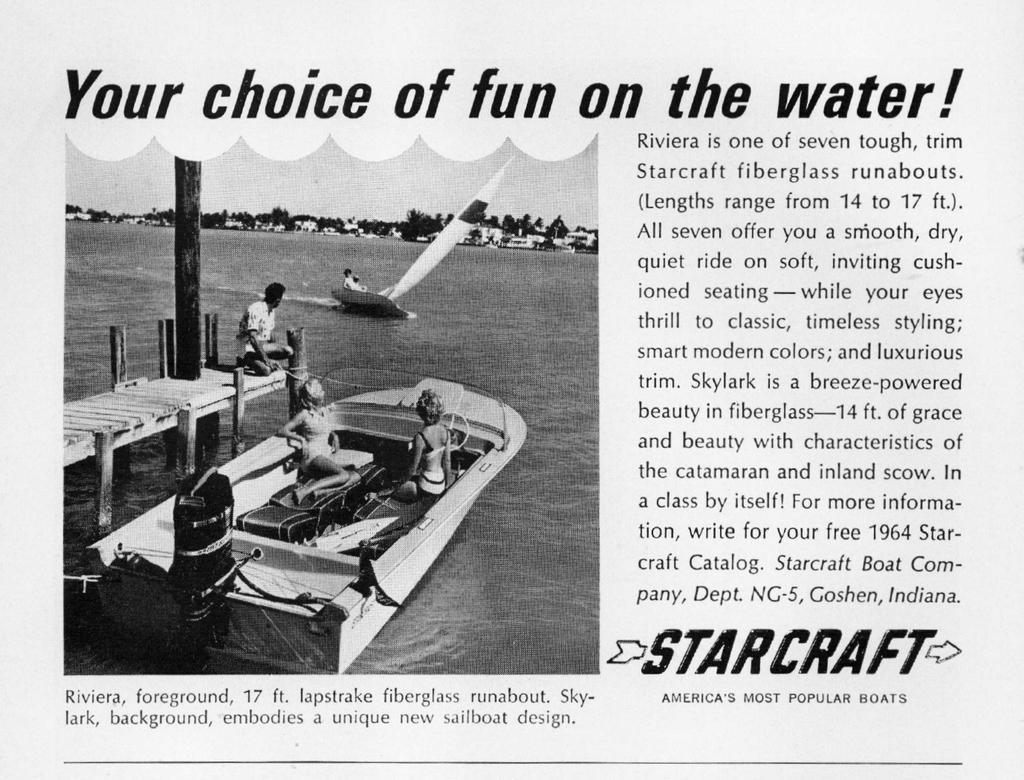In one or two sentences, can you explain what this image depicts? This is the black and white picture in which we can see an article of some edited text here on the right side of the image and on the left side of the image we can see a boat in which two women are sitting is floating on the water. Here we can see a person on the bridge, we can see another sailboat, trees and in the background of the image. 